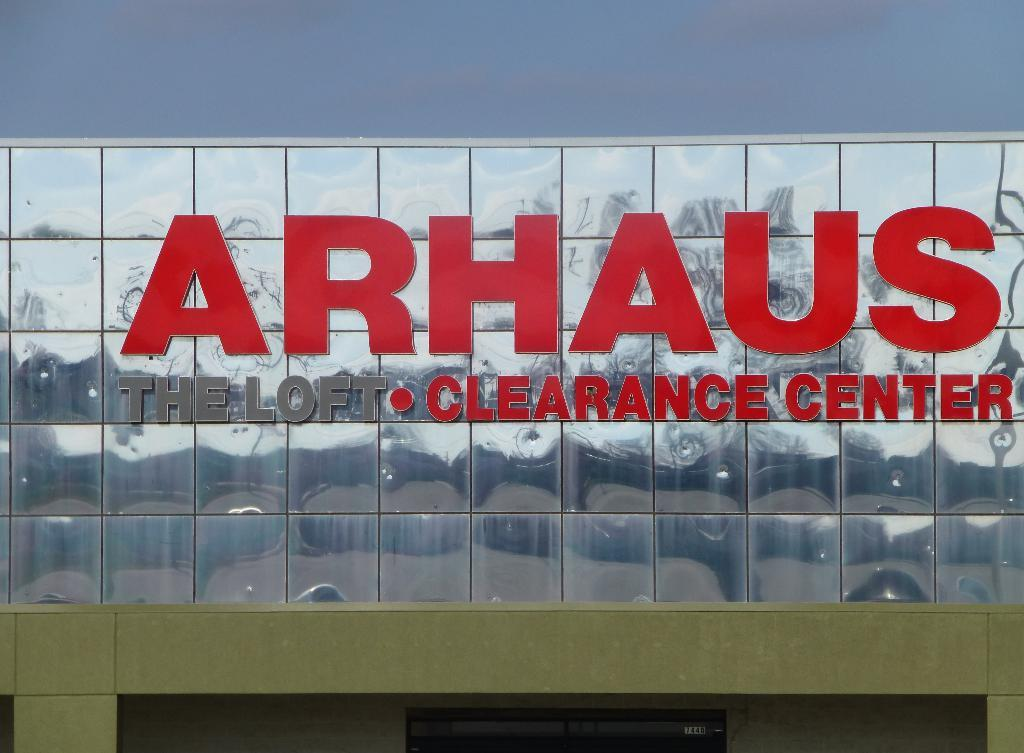<image>
Present a compact description of the photo's key features. The Arhaus furniture store has a clearance center. 